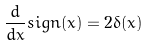<formula> <loc_0><loc_0><loc_500><loc_500>\frac { d } { d x } s i g n ( x ) = 2 \delta ( x )</formula> 